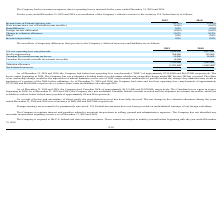According to Protagenic Therapeutics's financial document, What is the company's Canadian net operating loss carryforward as of December 31, 2019? According to the financial document, $1,111,000. The relevant text states: "018, the Company had Canadian NOL of approximately $1,111,000 and $1,070,000, respectively. The Canadian losses expire in stages 018, the Company had Canadian NOL of approximately $1,111,000 and $1,07..." Also, What is the company's Canadian net operating loss carryforward as of December 31, 2018? According to the financial document, $1,070,000. The relevant text states: "y had Canadian NOL of approximately $1,111,000 and $1,070,000, respectively. The Canadian losses expire in stages y had Canadian NOL of approximately $1,111,000 and $1,070,000, respectively. The Canad..." Also, When would the Canadian loss start to expire? According to the financial document, 2026. The relevant text states: "beginning in 2026. As of December 31, 2019 and 2018, the Company also has unclaimed Canadian federal scientific resea beginning in 2026. As of December 31, 2019 and 2018, the Company also has unclaime..." Also, can you calculate: What is the percentage change in the Canadian NOL between December 31, 2018 and 2019? To answer this question, I need to perform calculations using the financial data. The calculation is: (1,111,000 - 1,070,000)/1,070,000 , which equals 3.83 (percentage). This is based on the information: "had Canadian NOL of approximately $1,111,000 and $1,070,000, respectively. The Canadian losses expire in stages had Canadian NOL of approximately $1,111,000 and $1,070,000, respectively. The Canadian ..." The key data points involved are: 1,070,000, 1,111,000. Also, can you calculate: What is the difference in valuation allowance between 2018 and 2019? Based on the calculation: 3,703,000 - 3,042,000 , the result is 661000. This is based on the information: "3,703,000 3,042,000 3,703,000 3,042,000..." The key data points involved are: 3,042,000, 3,703,000. Also, can you calculate: What is the change in stock compensation between 2018 and 2019? Based on the calculation: 784,000 - 359,000 , the result is 425000. This is based on the information: "Stock compensation 784,000 359,000 Stock compensation 784,000 359,000..." The key data points involved are: 359,000, 784,000. 